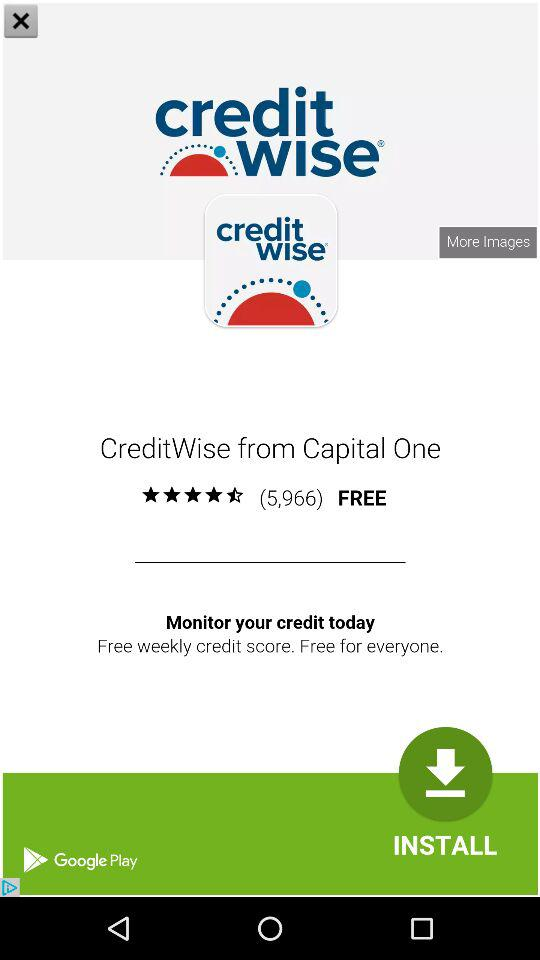What is the name of the application? The name of the application is "CreditWise". 